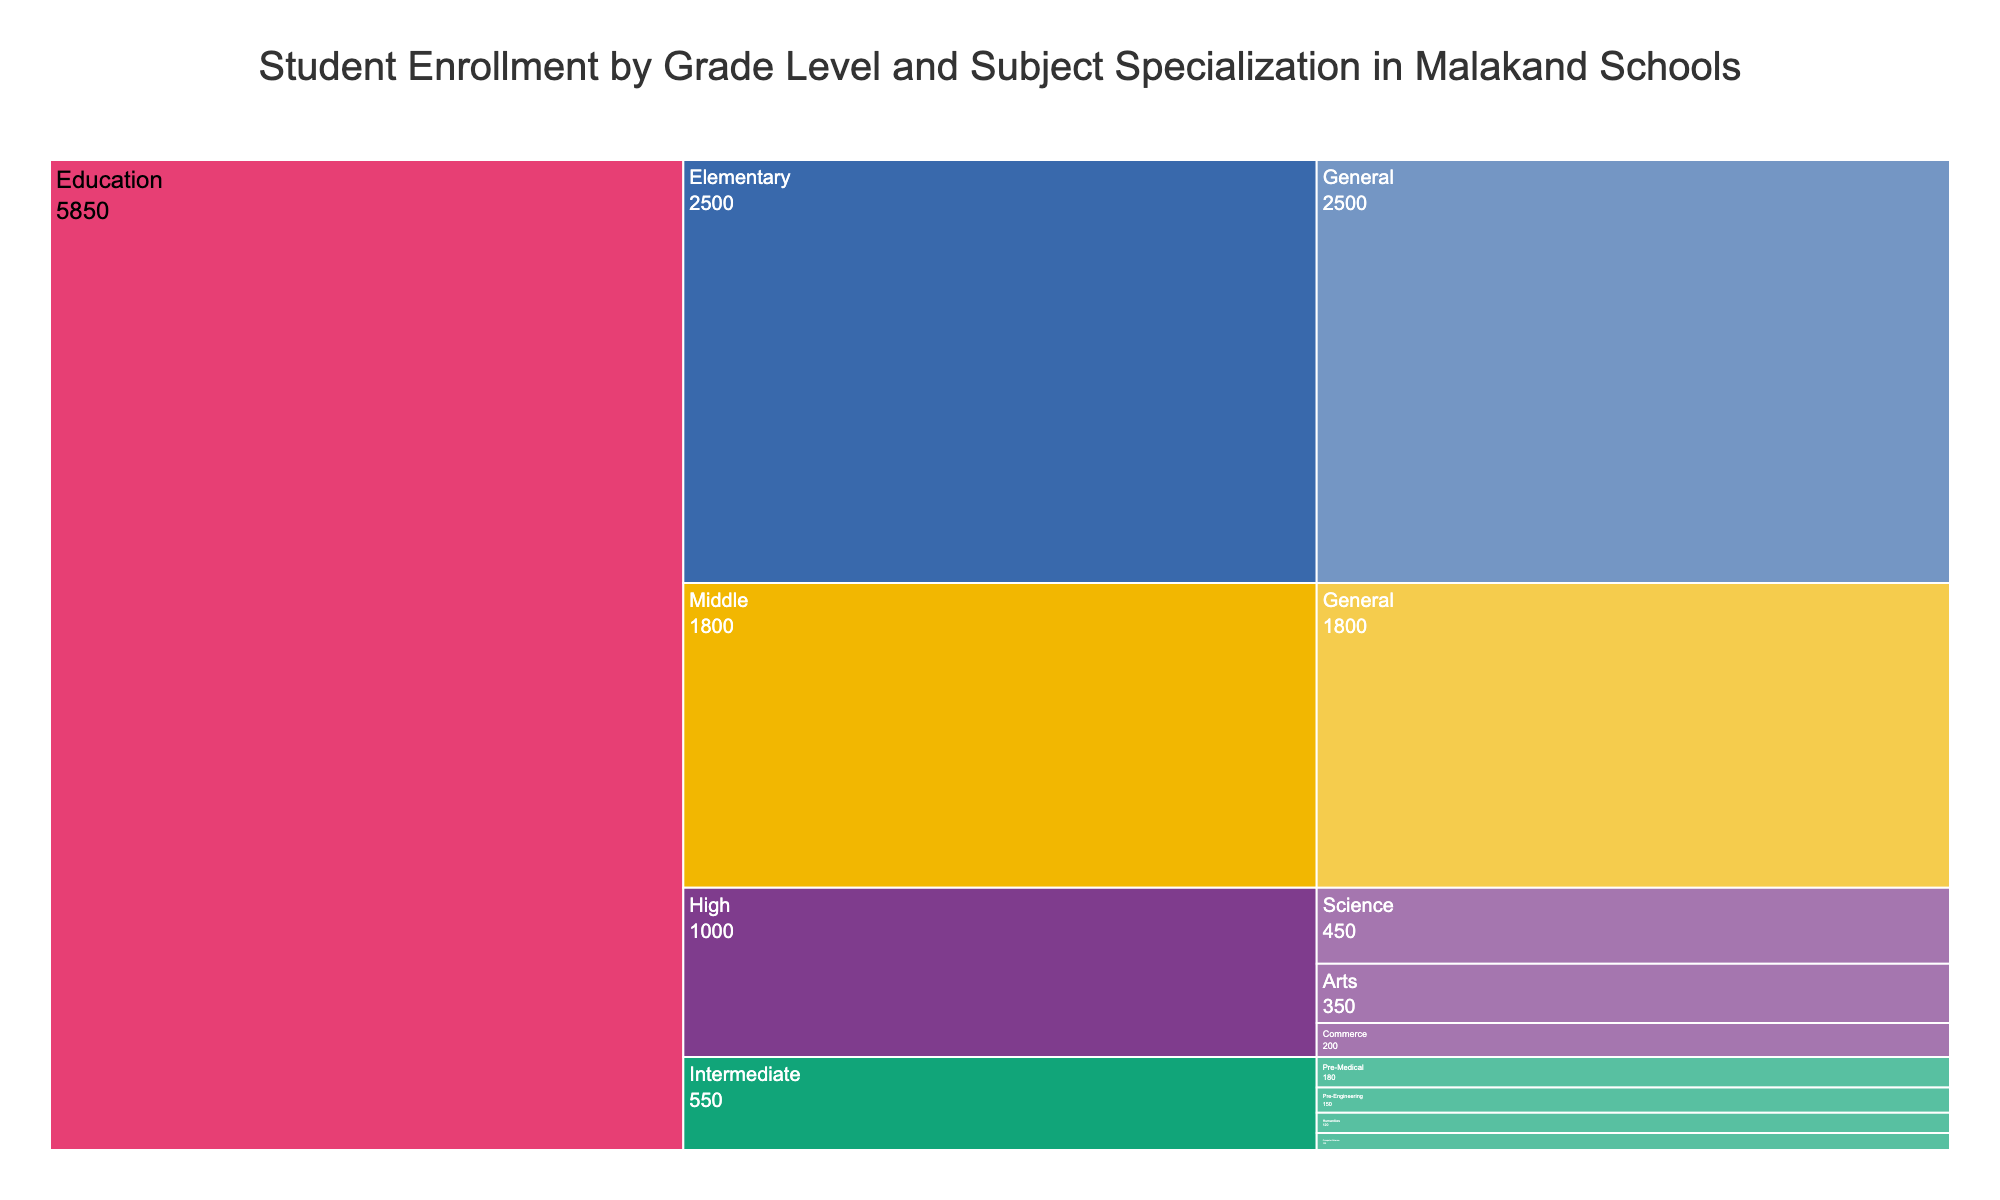what is the title of the chart? The title is located at the top of the chart. It provides a brief description of the chart's content.
Answer: Student Enrollment by Grade Level and Subject Specialization in Malakand Schools which grade level has the highest student enrollment in Malakand schools? By looking at the largest segment in the icicle chart, we can see the grade with the most significant student share.
Answer: Elementary how many students are enrolled in the high school science specialization? Follow the High branch down to the Science specialization and check the corresponding number of students.
Answer: 450 what is the total number of students enrolled in intermediate level across all specializations? Sum the number of students in all intermediate level specializations: Pre-Medical (180), Pre-Engineering (150), Humanities (120), and Computer Science (100).
Answer: 550 which specialization has more students in high school: arts or commerce? Compare the sizes of the segments for Arts and Commerce under the High grade level in the chart.
Answer: Arts what is the difference in student enrollment between middle school general and high school arts? Subtract the number of students in High school Arts (350) from Middle school General (1800).
Answer: 1450 which intermediate specialization has the least number of students? Investigate each segment under the Intermediate level to find the specialization with the smallest segment.
Answer: Computer Science how many total students are enrolled in education at all levels in Malakand schools? Add up the number of students across all the provided specializations: 2500 (Elementary) + 1800 (Middle) + 450 (High Science) + 350 (High Arts) + 200 (High Commerce) + 180 (Intermediate Pre-Medical) + 150 (Intermediate Pre-Engineering) + 120 (Intermediate Humanities) + 100 (Intermediate Computer Science).
Answer: 5850 which level has a broader range of specializations, high or intermediate? Compare the number of unique specializations within the High and Intermediate grade levels by counting them.
Answer: Intermediate what is the percentage of students enrolled in middle school out of the total school enrollment? Calculate the total number of students enrolled, then find the percentage represented by Middle school students: (1800 / 5850) * 100.
Answer: 30.77% 